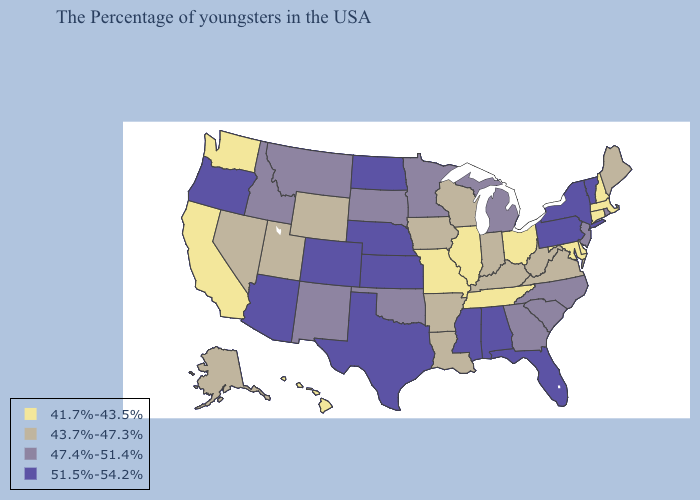Name the states that have a value in the range 47.4%-51.4%?
Answer briefly. Rhode Island, New Jersey, North Carolina, South Carolina, Georgia, Michigan, Minnesota, Oklahoma, South Dakota, New Mexico, Montana, Idaho. Among the states that border Florida , which have the highest value?
Give a very brief answer. Alabama. What is the highest value in the USA?
Be succinct. 51.5%-54.2%. Does Florida have a higher value than New Mexico?
Be succinct. Yes. Does Montana have the highest value in the USA?
Concise answer only. No. What is the lowest value in states that border Iowa?
Short answer required. 41.7%-43.5%. What is the value of Kansas?
Short answer required. 51.5%-54.2%. Which states have the highest value in the USA?
Keep it brief. Vermont, New York, Pennsylvania, Florida, Alabama, Mississippi, Kansas, Nebraska, Texas, North Dakota, Colorado, Arizona, Oregon. Does New York have the highest value in the USA?
Answer briefly. Yes. What is the value of Tennessee?
Give a very brief answer. 41.7%-43.5%. What is the highest value in the USA?
Answer briefly. 51.5%-54.2%. Does Massachusetts have a lower value than Hawaii?
Be succinct. No. Name the states that have a value in the range 41.7%-43.5%?
Keep it brief. Massachusetts, New Hampshire, Connecticut, Delaware, Maryland, Ohio, Tennessee, Illinois, Missouri, California, Washington, Hawaii. Which states have the lowest value in the Northeast?
Short answer required. Massachusetts, New Hampshire, Connecticut. Name the states that have a value in the range 51.5%-54.2%?
Keep it brief. Vermont, New York, Pennsylvania, Florida, Alabama, Mississippi, Kansas, Nebraska, Texas, North Dakota, Colorado, Arizona, Oregon. 